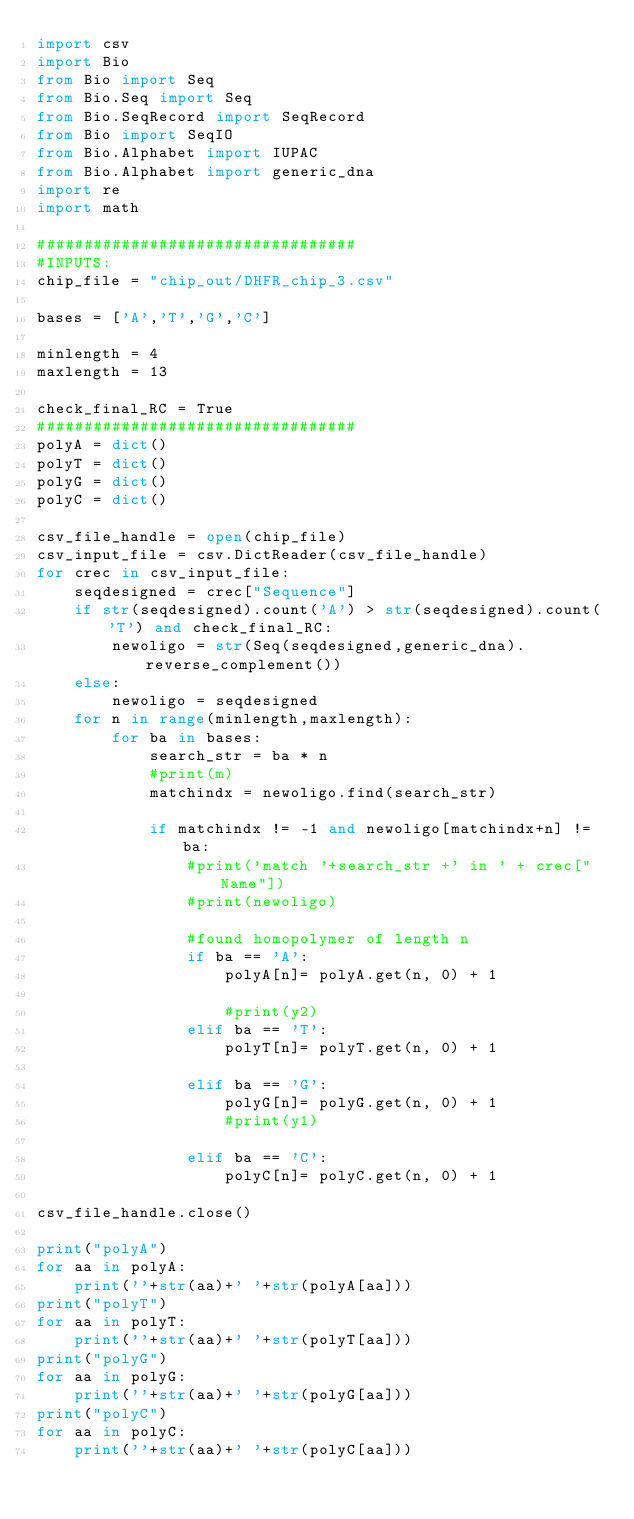<code> <loc_0><loc_0><loc_500><loc_500><_Python_>import csv
import Bio
from Bio import Seq
from Bio.Seq import Seq
from Bio.SeqRecord import SeqRecord
from Bio import SeqIO
from Bio.Alphabet import IUPAC
from Bio.Alphabet import generic_dna
import re
import math

##################################
#INPUTS:
chip_file = "chip_out/DHFR_chip_3.csv"

bases = ['A','T','G','C']

minlength = 4
maxlength = 13

check_final_RC = True
##################################
polyA = dict()
polyT = dict()
polyG = dict()
polyC = dict()

csv_file_handle = open(chip_file)
csv_input_file = csv.DictReader(csv_file_handle)
for crec in csv_input_file:
    seqdesigned = crec["Sequence"]
    if str(seqdesigned).count('A') > str(seqdesigned).count('T') and check_final_RC:
        newoligo = str(Seq(seqdesigned,generic_dna).reverse_complement())
    else:
        newoligo = seqdesigned
    for n in range(minlength,maxlength):
        for ba in bases:
            search_str = ba * n
            #print(m)
            matchindx = newoligo.find(search_str)
            
            if matchindx != -1 and newoligo[matchindx+n] != ba:
                #print('match '+search_str +' in ' + crec["Name"])
                #print(newoligo)
                
                #found homopolymer of length n
                if ba == 'A':
                    polyA[n]= polyA.get(n, 0) + 1
                    
                    #print(y2)
                elif ba == 'T':
                    polyT[n]= polyT.get(n, 0) + 1
                    
                elif ba == 'G':
                    polyG[n]= polyG.get(n, 0) + 1
                    #print(y1)
                    
                elif ba == 'C':
                    polyC[n]= polyC.get(n, 0) + 1
                    
csv_file_handle.close()

print("polyA")
for aa in polyA:
    print(''+str(aa)+' '+str(polyA[aa]))
print("polyT")
for aa in polyT:
    print(''+str(aa)+' '+str(polyT[aa]))
print("polyG")
for aa in polyG:
    print(''+str(aa)+' '+str(polyG[aa]))
print("polyC")
for aa in polyC:
    print(''+str(aa)+' '+str(polyC[aa]))
    </code> 